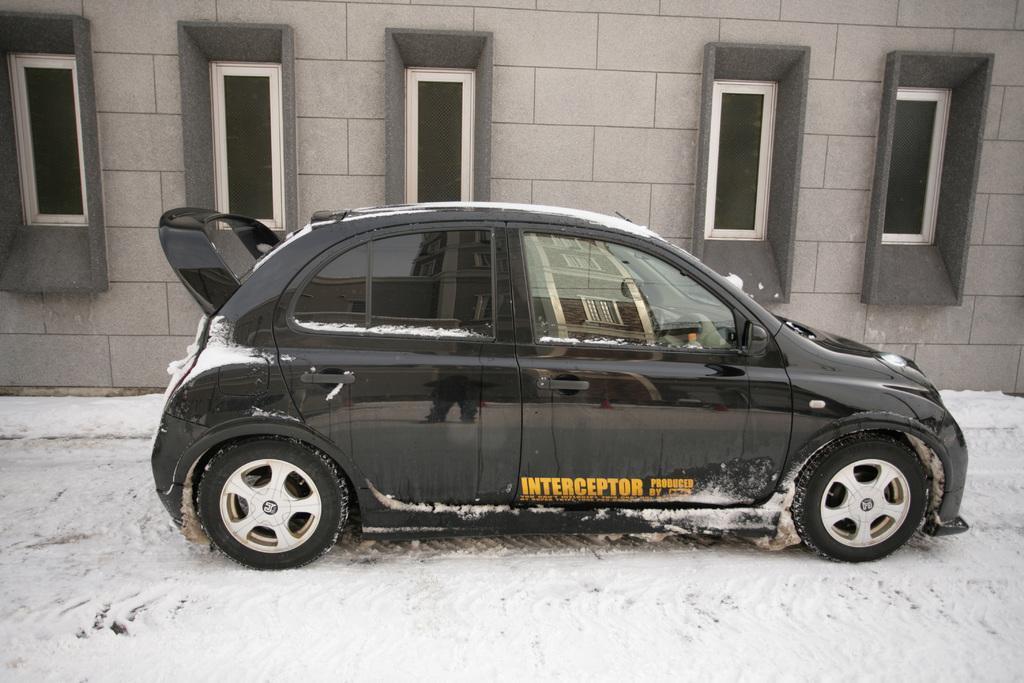How would you summarize this image in a sentence or two? In this image, we can see a black car is placed on the snow. Background we can see a wall, glass windows. On the car, we can see some reflections. There is a building and a person is standing here. 